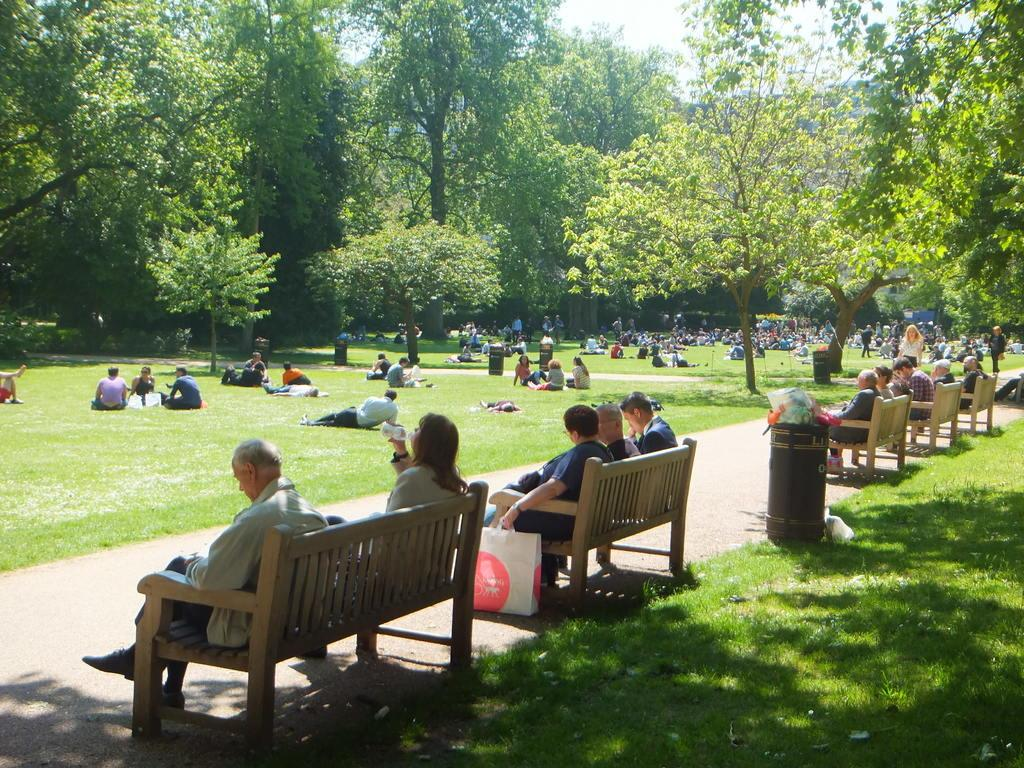What are the persons in the image doing? There are persons sitting on the ground, lying on the ground, and sitting on benches in the image. What objects are present in the image for waste disposal? There are bins in the image. What type of vegetation can be seen in the image? There are trees in the image. What is visible at the top of the image? The sky is visible in the image. What type of arch can be seen in the image? There is no arch present in the image. What toys are the persons playing with in the image? There are no toys visible in the image. 